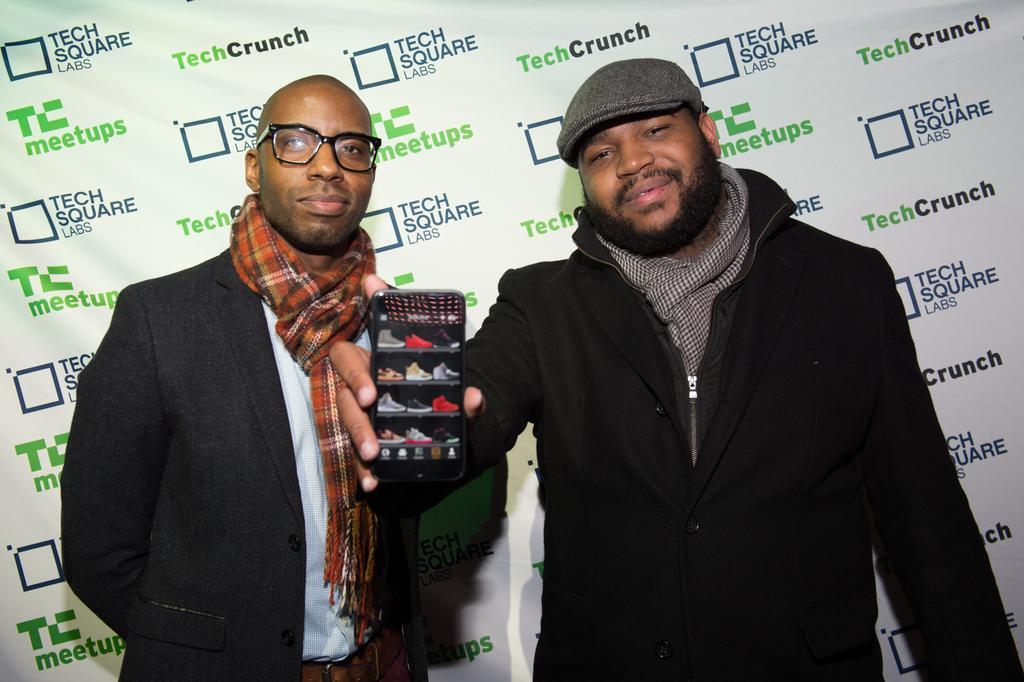Can you describe this image briefly? There is a man holding a phone and another man beside him in the foreground area of the image, it seems like a poster in the background. 